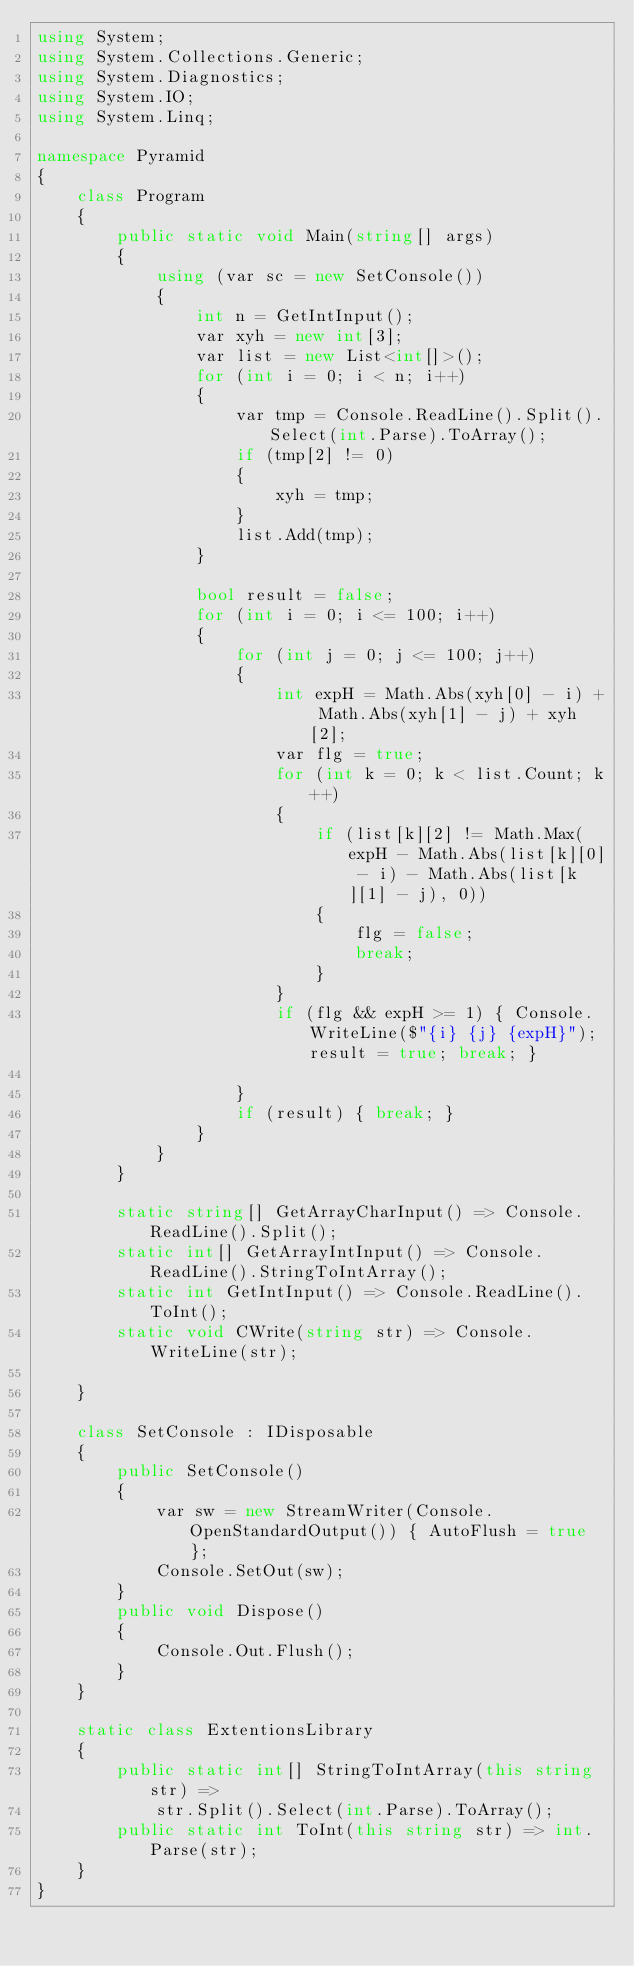<code> <loc_0><loc_0><loc_500><loc_500><_C#_>using System;
using System.Collections.Generic;
using System.Diagnostics;
using System.IO;
using System.Linq;

namespace Pyramid
{
    class Program
    {
        public static void Main(string[] args)
        {
            using (var sc = new SetConsole())
            {
                int n = GetIntInput();
                var xyh = new int[3];
                var list = new List<int[]>();
                for (int i = 0; i < n; i++)
                {
                    var tmp = Console.ReadLine().Split().Select(int.Parse).ToArray();
                    if (tmp[2] != 0)
                    {
                        xyh = tmp;
                    }
                    list.Add(tmp);
                }
                
                bool result = false;
                for (int i = 0; i <= 100; i++)
                {
                    for (int j = 0; j <= 100; j++)
                    {
                        int expH = Math.Abs(xyh[0] - i) + Math.Abs(xyh[1] - j) + xyh[2];
                        var flg = true;
                        for (int k = 0; k < list.Count; k++)
                        {
                            if (list[k][2] != Math.Max(expH - Math.Abs(list[k][0] - i) - Math.Abs(list[k][1] - j), 0))
                            {
                                flg = false;
                                break;
                            }
                        }
                        if (flg && expH >= 1) { Console.WriteLine($"{i} {j} {expH}"); result = true; break; }

                    }
                    if (result) { break; }
                }
            }
        }

        static string[] GetArrayCharInput() => Console.ReadLine().Split();
        static int[] GetArrayIntInput() => Console.ReadLine().StringToIntArray();
        static int GetIntInput() => Console.ReadLine().ToInt();
        static void CWrite(string str) => Console.WriteLine(str);

    }

    class SetConsole : IDisposable
    {
        public SetConsole()
        {
            var sw = new StreamWriter(Console.OpenStandardOutput()) { AutoFlush = true };
            Console.SetOut(sw);
        }
        public void Dispose()
        {
            Console.Out.Flush();
        }
    }

    static class ExtentionsLibrary
    {
        public static int[] StringToIntArray(this string str) =>
            str.Split().Select(int.Parse).ToArray();
        public static int ToInt(this string str) => int.Parse(str);
    }
}
</code> 